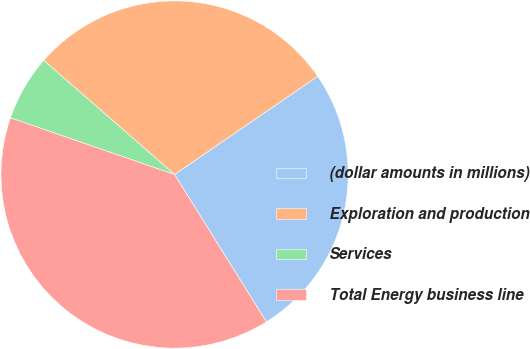Convert chart to OTSL. <chart><loc_0><loc_0><loc_500><loc_500><pie_chart><fcel>(dollar amounts in millions)<fcel>Exploration and production<fcel>Services<fcel>Total Energy business line<nl><fcel>25.7%<fcel>29.01%<fcel>6.12%<fcel>39.16%<nl></chart> 